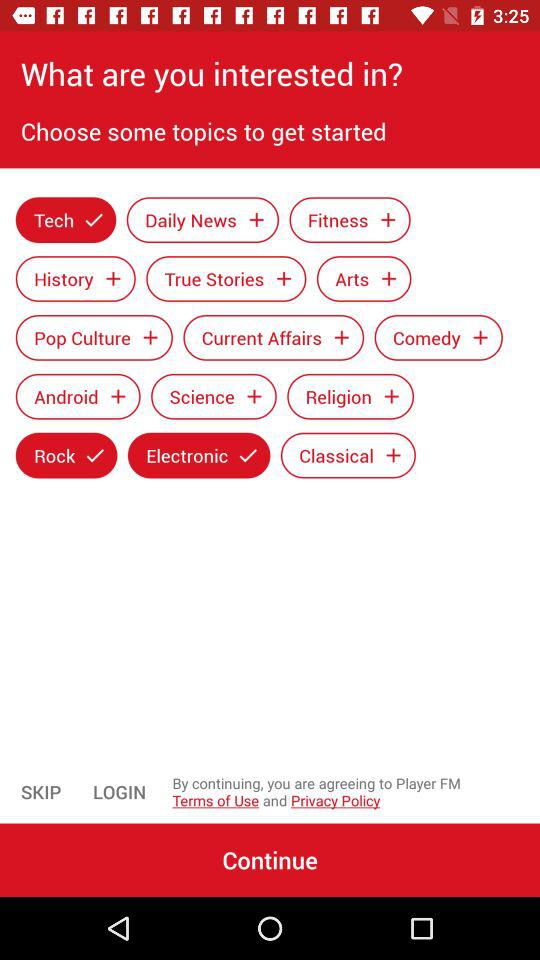Which topics are selected? The selected topics are "Tech", "Rock" and "Electronic". 